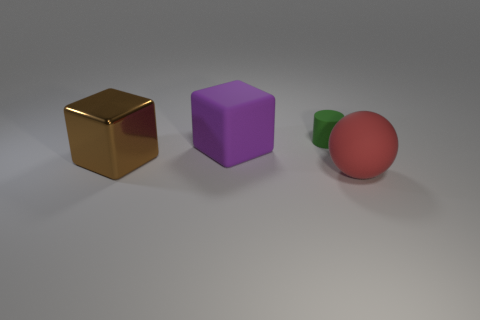Add 1 purple things. How many objects exist? 5 Subtract 2 cubes. How many cubes are left? 0 Subtract all brown blocks. How many blocks are left? 1 Subtract all cylinders. How many objects are left? 3 Subtract 0 purple cylinders. How many objects are left? 4 Subtract all red cylinders. Subtract all blue spheres. How many cylinders are left? 1 Subtract all green cylinders. Subtract all blue matte objects. How many objects are left? 3 Add 2 metal things. How many metal things are left? 3 Add 2 brown metal cubes. How many brown metal cubes exist? 3 